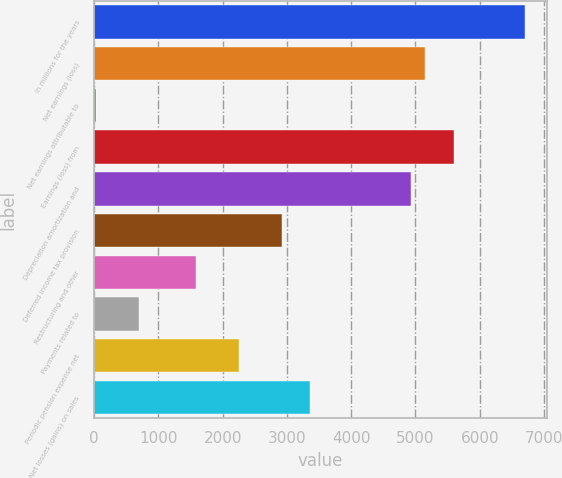Convert chart to OTSL. <chart><loc_0><loc_0><loc_500><loc_500><bar_chart><fcel>In millions for the years<fcel>Net earnings (loss)<fcel>Net earnings attributable to<fcel>Earnings (loss) from<fcel>Depreciation amortization and<fcel>Deferred income tax provision<fcel>Restructuring and other<fcel>Payments related to<fcel>Periodic pension expense net<fcel>Net losses (gains) on sales<nl><fcel>6708<fcel>5148.4<fcel>24<fcel>5594<fcel>4925.6<fcel>2920.4<fcel>1583.6<fcel>692.4<fcel>2252<fcel>3366<nl></chart> 